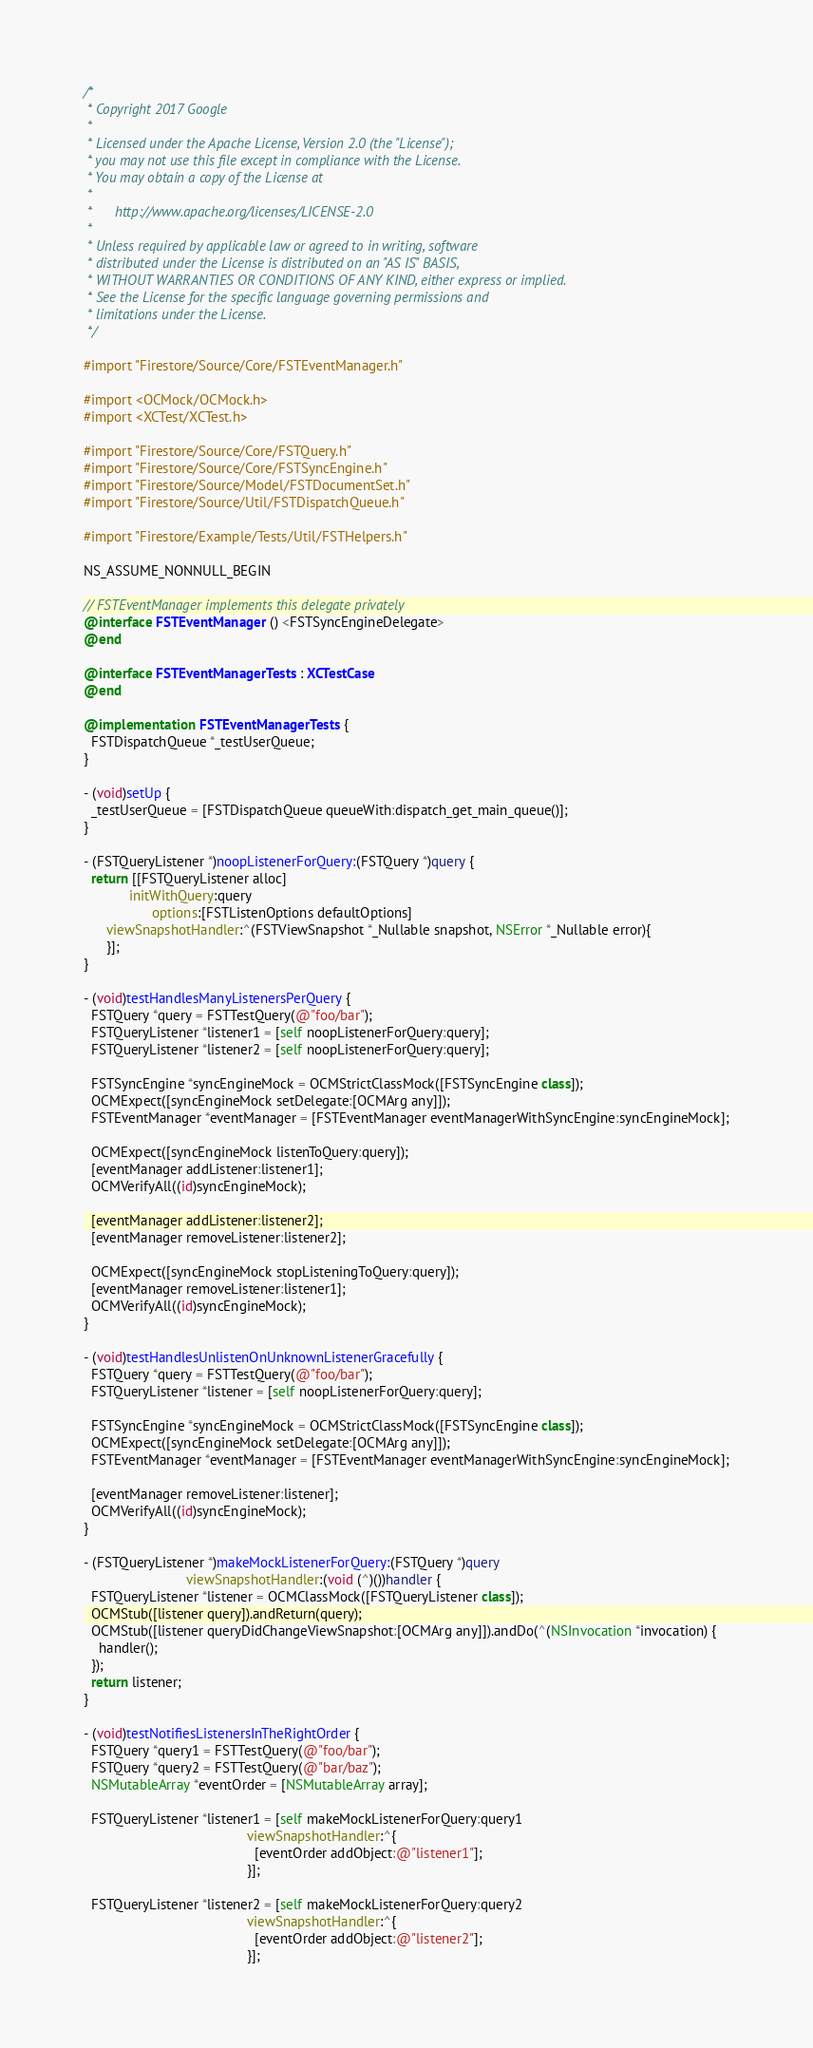Convert code to text. <code><loc_0><loc_0><loc_500><loc_500><_ObjectiveC_>/*
 * Copyright 2017 Google
 *
 * Licensed under the Apache License, Version 2.0 (the "License");
 * you may not use this file except in compliance with the License.
 * You may obtain a copy of the License at
 *
 *      http://www.apache.org/licenses/LICENSE-2.0
 *
 * Unless required by applicable law or agreed to in writing, software
 * distributed under the License is distributed on an "AS IS" BASIS,
 * WITHOUT WARRANTIES OR CONDITIONS OF ANY KIND, either express or implied.
 * See the License for the specific language governing permissions and
 * limitations under the License.
 */

#import "Firestore/Source/Core/FSTEventManager.h"

#import <OCMock/OCMock.h>
#import <XCTest/XCTest.h>

#import "Firestore/Source/Core/FSTQuery.h"
#import "Firestore/Source/Core/FSTSyncEngine.h"
#import "Firestore/Source/Model/FSTDocumentSet.h"
#import "Firestore/Source/Util/FSTDispatchQueue.h"

#import "Firestore/Example/Tests/Util/FSTHelpers.h"

NS_ASSUME_NONNULL_BEGIN

// FSTEventManager implements this delegate privately
@interface FSTEventManager () <FSTSyncEngineDelegate>
@end

@interface FSTEventManagerTests : XCTestCase
@end

@implementation FSTEventManagerTests {
  FSTDispatchQueue *_testUserQueue;
}

- (void)setUp {
  _testUserQueue = [FSTDispatchQueue queueWith:dispatch_get_main_queue()];
}

- (FSTQueryListener *)noopListenerForQuery:(FSTQuery *)query {
  return [[FSTQueryListener alloc]
            initWithQuery:query
                  options:[FSTListenOptions defaultOptions]
      viewSnapshotHandler:^(FSTViewSnapshot *_Nullable snapshot, NSError *_Nullable error){
      }];
}

- (void)testHandlesManyListenersPerQuery {
  FSTQuery *query = FSTTestQuery(@"foo/bar");
  FSTQueryListener *listener1 = [self noopListenerForQuery:query];
  FSTQueryListener *listener2 = [self noopListenerForQuery:query];

  FSTSyncEngine *syncEngineMock = OCMStrictClassMock([FSTSyncEngine class]);
  OCMExpect([syncEngineMock setDelegate:[OCMArg any]]);
  FSTEventManager *eventManager = [FSTEventManager eventManagerWithSyncEngine:syncEngineMock];

  OCMExpect([syncEngineMock listenToQuery:query]);
  [eventManager addListener:listener1];
  OCMVerifyAll((id)syncEngineMock);

  [eventManager addListener:listener2];
  [eventManager removeListener:listener2];

  OCMExpect([syncEngineMock stopListeningToQuery:query]);
  [eventManager removeListener:listener1];
  OCMVerifyAll((id)syncEngineMock);
}

- (void)testHandlesUnlistenOnUnknownListenerGracefully {
  FSTQuery *query = FSTTestQuery(@"foo/bar");
  FSTQueryListener *listener = [self noopListenerForQuery:query];

  FSTSyncEngine *syncEngineMock = OCMStrictClassMock([FSTSyncEngine class]);
  OCMExpect([syncEngineMock setDelegate:[OCMArg any]]);
  FSTEventManager *eventManager = [FSTEventManager eventManagerWithSyncEngine:syncEngineMock];

  [eventManager removeListener:listener];
  OCMVerifyAll((id)syncEngineMock);
}

- (FSTQueryListener *)makeMockListenerForQuery:(FSTQuery *)query
                           viewSnapshotHandler:(void (^)())handler {
  FSTQueryListener *listener = OCMClassMock([FSTQueryListener class]);
  OCMStub([listener query]).andReturn(query);
  OCMStub([listener queryDidChangeViewSnapshot:[OCMArg any]]).andDo(^(NSInvocation *invocation) {
    handler();
  });
  return listener;
}

- (void)testNotifiesListenersInTheRightOrder {
  FSTQuery *query1 = FSTTestQuery(@"foo/bar");
  FSTQuery *query2 = FSTTestQuery(@"bar/baz");
  NSMutableArray *eventOrder = [NSMutableArray array];

  FSTQueryListener *listener1 = [self makeMockListenerForQuery:query1
                                           viewSnapshotHandler:^{
                                             [eventOrder addObject:@"listener1"];
                                           }];

  FSTQueryListener *listener2 = [self makeMockListenerForQuery:query2
                                           viewSnapshotHandler:^{
                                             [eventOrder addObject:@"listener2"];
                                           }];
</code> 